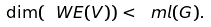<formula> <loc_0><loc_0><loc_500><loc_500>\dim ( \ W E ( V ) ) < \ m l ( G ) .</formula> 